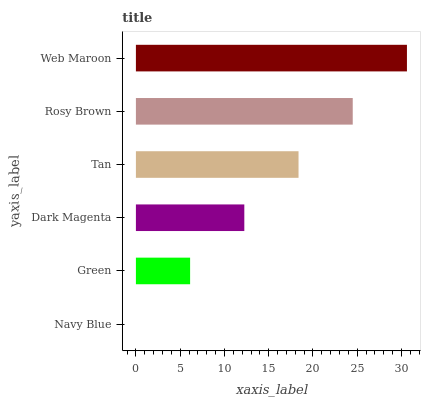Is Navy Blue the minimum?
Answer yes or no. Yes. Is Web Maroon the maximum?
Answer yes or no. Yes. Is Green the minimum?
Answer yes or no. No. Is Green the maximum?
Answer yes or no. No. Is Green greater than Navy Blue?
Answer yes or no. Yes. Is Navy Blue less than Green?
Answer yes or no. Yes. Is Navy Blue greater than Green?
Answer yes or no. No. Is Green less than Navy Blue?
Answer yes or no. No. Is Tan the high median?
Answer yes or no. Yes. Is Dark Magenta the low median?
Answer yes or no. Yes. Is Navy Blue the high median?
Answer yes or no. No. Is Tan the low median?
Answer yes or no. No. 